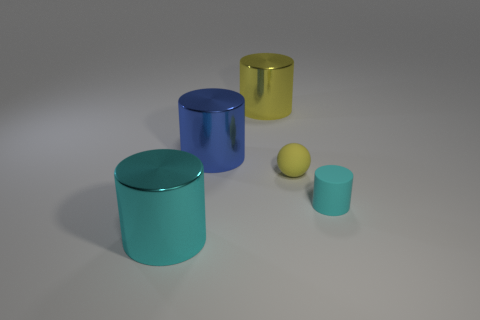Add 1 tiny cylinders. How many objects exist? 6 Subtract all balls. How many objects are left? 4 Subtract all cubes. Subtract all big cylinders. How many objects are left? 2 Add 2 small spheres. How many small spheres are left? 3 Add 4 big metal things. How many big metal things exist? 7 Subtract 1 yellow balls. How many objects are left? 4 